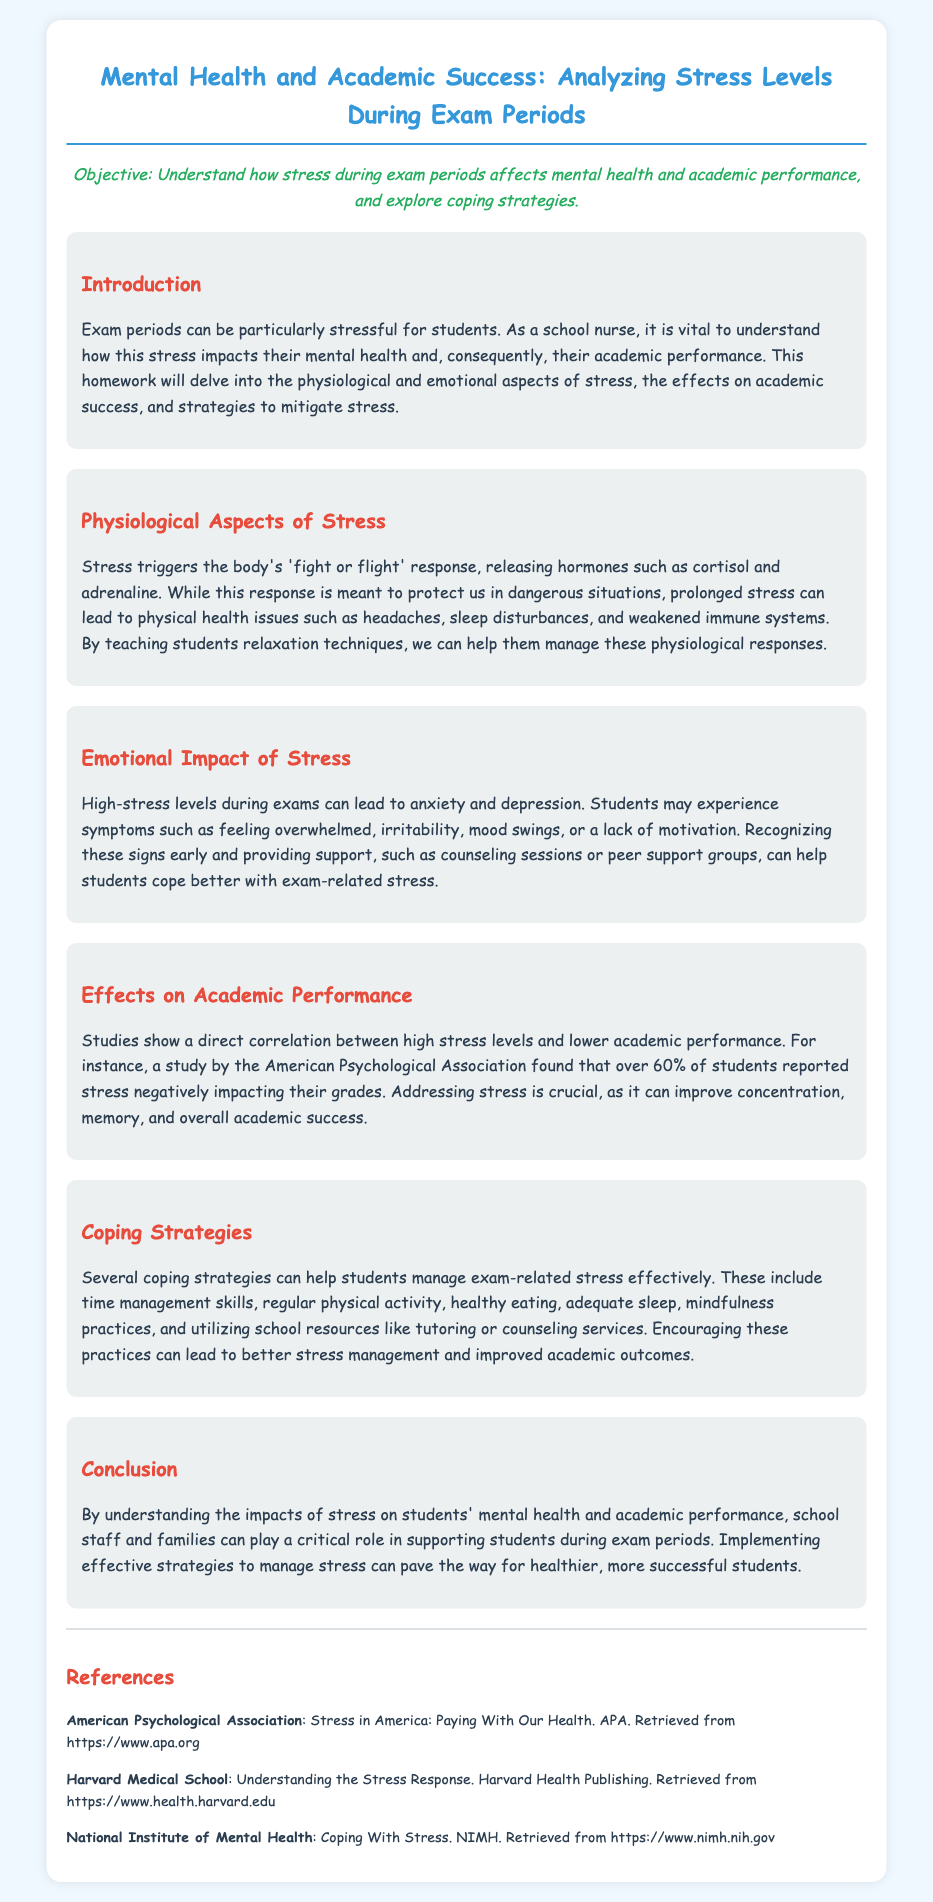what is the main objective of the homework? The main objective is to understand how stress during exam periods affects mental health and academic performance, and explore coping strategies.
Answer: to understand how stress affects mental health and academic performance what hormone is released during stress? The document mentions cortisol and adrenaline as hormones released during stress.
Answer: cortisol and adrenaline what percentage of students reported stress negatively impacting their grades? According to the document, over 60% of students reported that stress negatively impacted their grades.
Answer: over 60% name one coping strategy mentioned in the document. The document lists several coping strategies, including time management skills.
Answer: time management skills what emotional symptom can high stress levels lead to? The document states that high-stress levels during exams can lead to anxiety or depression.
Answer: anxiety or depression how does prolonged stress affect physical health? The document explains that prolonged stress can lead to physical health issues such as headaches or sleep disturbances.
Answer: headaches or sleep disturbances which organization provided research about stress impacting grades? The American Psychological Association is mentioned as providing related research.
Answer: American Psychological Association what is one effect of teaching relaxation techniques? Teaching relaxation techniques helps students manage physiological responses to stress.
Answer: manage physiological responses 